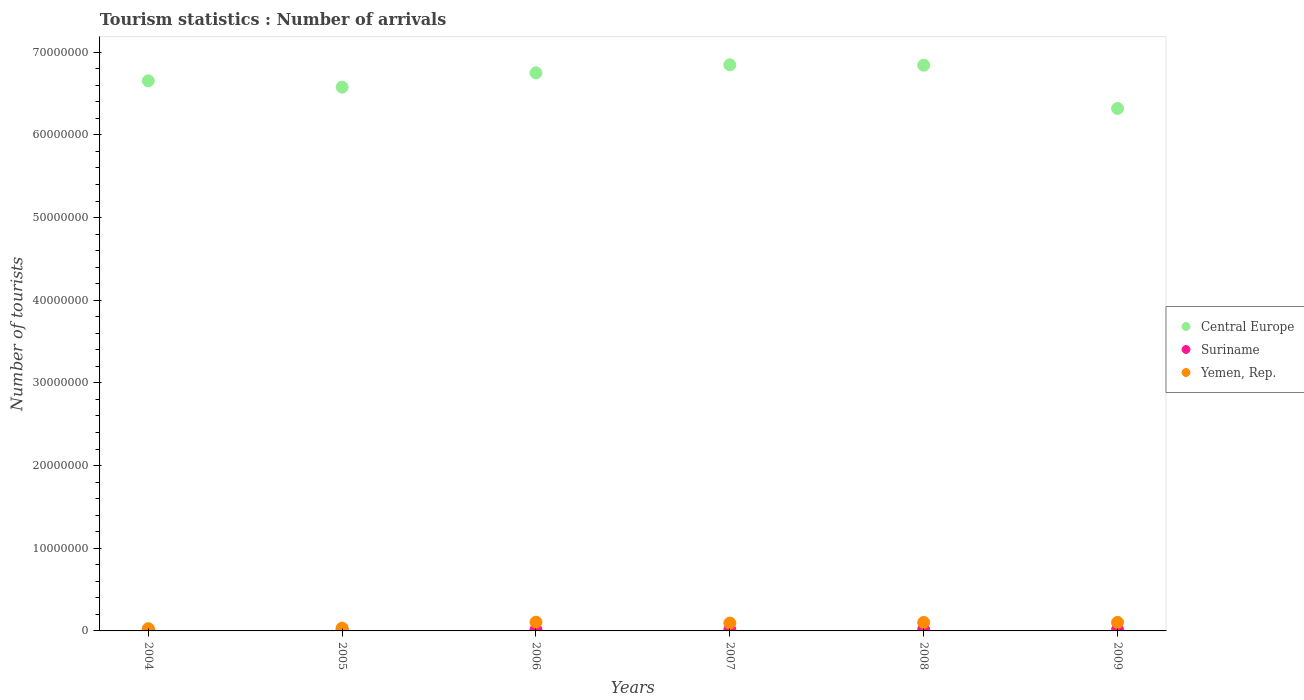Is the number of dotlines equal to the number of legend labels?
Your answer should be very brief. Yes. What is the number of tourist arrivals in Suriname in 2006?
Make the answer very short. 1.54e+05. Across all years, what is the maximum number of tourist arrivals in Suriname?
Offer a very short reply. 1.67e+05. Across all years, what is the minimum number of tourist arrivals in Suriname?
Keep it short and to the point. 1.38e+05. What is the total number of tourist arrivals in Yemen, Rep. in the graph?
Your answer should be compact. 4.67e+06. What is the difference between the number of tourist arrivals in Suriname in 2005 and that in 2006?
Keep it short and to the point. 7000. What is the difference between the number of tourist arrivals in Suriname in 2004 and the number of tourist arrivals in Central Europe in 2008?
Your response must be concise. -6.83e+07. What is the average number of tourist arrivals in Suriname per year?
Ensure brevity in your answer.  1.54e+05. In the year 2008, what is the difference between the number of tourist arrivals in Suriname and number of tourist arrivals in Central Europe?
Keep it short and to the point. -6.83e+07. What is the ratio of the number of tourist arrivals in Suriname in 2004 to that in 2009?
Keep it short and to the point. 0.91. What is the difference between the highest and the second highest number of tourist arrivals in Suriname?
Provide a succinct answer. 6000. What is the difference between the highest and the lowest number of tourist arrivals in Suriname?
Provide a succinct answer. 2.90e+04. Is the sum of the number of tourist arrivals in Yemen, Rep. in 2005 and 2006 greater than the maximum number of tourist arrivals in Central Europe across all years?
Make the answer very short. No. Is it the case that in every year, the sum of the number of tourist arrivals in Yemen, Rep. and number of tourist arrivals in Central Europe  is greater than the number of tourist arrivals in Suriname?
Ensure brevity in your answer.  Yes. Does the number of tourist arrivals in Suriname monotonically increase over the years?
Provide a short and direct response. No. Is the number of tourist arrivals in Yemen, Rep. strictly greater than the number of tourist arrivals in Suriname over the years?
Your answer should be very brief. Yes. Is the number of tourist arrivals in Suriname strictly less than the number of tourist arrivals in Central Europe over the years?
Provide a short and direct response. Yes. How many years are there in the graph?
Provide a short and direct response. 6. What is the difference between two consecutive major ticks on the Y-axis?
Keep it short and to the point. 1.00e+07. Are the values on the major ticks of Y-axis written in scientific E-notation?
Your answer should be very brief. No. Where does the legend appear in the graph?
Offer a terse response. Center right. How many legend labels are there?
Provide a short and direct response. 3. How are the legend labels stacked?
Make the answer very short. Vertical. What is the title of the graph?
Your response must be concise. Tourism statistics : Number of arrivals. What is the label or title of the X-axis?
Offer a terse response. Years. What is the label or title of the Y-axis?
Give a very brief answer. Number of tourists. What is the Number of tourists of Central Europe in 2004?
Provide a short and direct response. 6.65e+07. What is the Number of tourists of Suriname in 2004?
Provide a short and direct response. 1.38e+05. What is the Number of tourists of Yemen, Rep. in 2004?
Your answer should be very brief. 2.74e+05. What is the Number of tourists of Central Europe in 2005?
Your answer should be very brief. 6.58e+07. What is the Number of tourists in Suriname in 2005?
Offer a very short reply. 1.61e+05. What is the Number of tourists of Yemen, Rep. in 2005?
Your answer should be very brief. 3.36e+05. What is the Number of tourists in Central Europe in 2006?
Offer a terse response. 6.75e+07. What is the Number of tourists of Suriname in 2006?
Your response must be concise. 1.54e+05. What is the Number of tourists of Yemen, Rep. in 2006?
Make the answer very short. 1.06e+06. What is the Number of tourists of Central Europe in 2007?
Your response must be concise. 6.85e+07. What is the Number of tourists in Suriname in 2007?
Provide a short and direct response. 1.67e+05. What is the Number of tourists of Yemen, Rep. in 2007?
Ensure brevity in your answer.  9.48e+05. What is the Number of tourists in Central Europe in 2008?
Provide a short and direct response. 6.84e+07. What is the Number of tourists of Suriname in 2008?
Give a very brief answer. 1.51e+05. What is the Number of tourists of Yemen, Rep. in 2008?
Give a very brief answer. 1.02e+06. What is the Number of tourists of Central Europe in 2009?
Your answer should be compact. 6.32e+07. What is the Number of tourists in Suriname in 2009?
Your answer should be compact. 1.51e+05. What is the Number of tourists of Yemen, Rep. in 2009?
Provide a short and direct response. 1.03e+06. Across all years, what is the maximum Number of tourists in Central Europe?
Keep it short and to the point. 6.85e+07. Across all years, what is the maximum Number of tourists in Suriname?
Offer a terse response. 1.67e+05. Across all years, what is the maximum Number of tourists of Yemen, Rep.?
Your response must be concise. 1.06e+06. Across all years, what is the minimum Number of tourists in Central Europe?
Your answer should be compact. 6.32e+07. Across all years, what is the minimum Number of tourists of Suriname?
Your answer should be very brief. 1.38e+05. Across all years, what is the minimum Number of tourists in Yemen, Rep.?
Make the answer very short. 2.74e+05. What is the total Number of tourists in Central Europe in the graph?
Offer a terse response. 4.00e+08. What is the total Number of tourists of Suriname in the graph?
Your response must be concise. 9.22e+05. What is the total Number of tourists of Yemen, Rep. in the graph?
Give a very brief answer. 4.67e+06. What is the difference between the Number of tourists in Central Europe in 2004 and that in 2005?
Provide a short and direct response. 7.64e+05. What is the difference between the Number of tourists of Suriname in 2004 and that in 2005?
Your answer should be very brief. -2.30e+04. What is the difference between the Number of tourists in Yemen, Rep. in 2004 and that in 2005?
Make the answer very short. -6.20e+04. What is the difference between the Number of tourists in Central Europe in 2004 and that in 2006?
Provide a short and direct response. -9.64e+05. What is the difference between the Number of tourists of Suriname in 2004 and that in 2006?
Keep it short and to the point. -1.60e+04. What is the difference between the Number of tourists in Yemen, Rep. in 2004 and that in 2006?
Offer a terse response. -7.87e+05. What is the difference between the Number of tourists of Central Europe in 2004 and that in 2007?
Your response must be concise. -1.94e+06. What is the difference between the Number of tourists of Suriname in 2004 and that in 2007?
Your answer should be very brief. -2.90e+04. What is the difference between the Number of tourists of Yemen, Rep. in 2004 and that in 2007?
Offer a terse response. -6.74e+05. What is the difference between the Number of tourists in Central Europe in 2004 and that in 2008?
Keep it short and to the point. -1.89e+06. What is the difference between the Number of tourists of Suriname in 2004 and that in 2008?
Your response must be concise. -1.30e+04. What is the difference between the Number of tourists in Yemen, Rep. in 2004 and that in 2008?
Your answer should be very brief. -7.49e+05. What is the difference between the Number of tourists of Central Europe in 2004 and that in 2009?
Provide a succinct answer. 3.35e+06. What is the difference between the Number of tourists of Suriname in 2004 and that in 2009?
Keep it short and to the point. -1.30e+04. What is the difference between the Number of tourists in Yemen, Rep. in 2004 and that in 2009?
Give a very brief answer. -7.54e+05. What is the difference between the Number of tourists of Central Europe in 2005 and that in 2006?
Provide a short and direct response. -1.73e+06. What is the difference between the Number of tourists in Suriname in 2005 and that in 2006?
Provide a succinct answer. 7000. What is the difference between the Number of tourists in Yemen, Rep. in 2005 and that in 2006?
Ensure brevity in your answer.  -7.25e+05. What is the difference between the Number of tourists of Central Europe in 2005 and that in 2007?
Keep it short and to the point. -2.70e+06. What is the difference between the Number of tourists of Suriname in 2005 and that in 2007?
Provide a succinct answer. -6000. What is the difference between the Number of tourists of Yemen, Rep. in 2005 and that in 2007?
Provide a short and direct response. -6.12e+05. What is the difference between the Number of tourists in Central Europe in 2005 and that in 2008?
Ensure brevity in your answer.  -2.66e+06. What is the difference between the Number of tourists in Suriname in 2005 and that in 2008?
Make the answer very short. 10000. What is the difference between the Number of tourists of Yemen, Rep. in 2005 and that in 2008?
Provide a succinct answer. -6.87e+05. What is the difference between the Number of tourists in Central Europe in 2005 and that in 2009?
Your answer should be very brief. 2.58e+06. What is the difference between the Number of tourists of Suriname in 2005 and that in 2009?
Provide a short and direct response. 10000. What is the difference between the Number of tourists in Yemen, Rep. in 2005 and that in 2009?
Give a very brief answer. -6.92e+05. What is the difference between the Number of tourists of Central Europe in 2006 and that in 2007?
Provide a short and direct response. -9.72e+05. What is the difference between the Number of tourists of Suriname in 2006 and that in 2007?
Ensure brevity in your answer.  -1.30e+04. What is the difference between the Number of tourists of Yemen, Rep. in 2006 and that in 2007?
Provide a short and direct response. 1.13e+05. What is the difference between the Number of tourists of Central Europe in 2006 and that in 2008?
Give a very brief answer. -9.27e+05. What is the difference between the Number of tourists in Suriname in 2006 and that in 2008?
Provide a short and direct response. 3000. What is the difference between the Number of tourists of Yemen, Rep. in 2006 and that in 2008?
Your response must be concise. 3.80e+04. What is the difference between the Number of tourists of Central Europe in 2006 and that in 2009?
Offer a terse response. 4.31e+06. What is the difference between the Number of tourists in Suriname in 2006 and that in 2009?
Provide a short and direct response. 3000. What is the difference between the Number of tourists in Yemen, Rep. in 2006 and that in 2009?
Your answer should be very brief. 3.30e+04. What is the difference between the Number of tourists of Central Europe in 2007 and that in 2008?
Your answer should be very brief. 4.50e+04. What is the difference between the Number of tourists in Suriname in 2007 and that in 2008?
Your response must be concise. 1.60e+04. What is the difference between the Number of tourists of Yemen, Rep. in 2007 and that in 2008?
Make the answer very short. -7.50e+04. What is the difference between the Number of tourists of Central Europe in 2007 and that in 2009?
Your answer should be very brief. 5.28e+06. What is the difference between the Number of tourists of Suriname in 2007 and that in 2009?
Provide a short and direct response. 1.60e+04. What is the difference between the Number of tourists of Central Europe in 2008 and that in 2009?
Ensure brevity in your answer.  5.24e+06. What is the difference between the Number of tourists in Suriname in 2008 and that in 2009?
Your response must be concise. 0. What is the difference between the Number of tourists in Yemen, Rep. in 2008 and that in 2009?
Ensure brevity in your answer.  -5000. What is the difference between the Number of tourists in Central Europe in 2004 and the Number of tourists in Suriname in 2005?
Ensure brevity in your answer.  6.64e+07. What is the difference between the Number of tourists in Central Europe in 2004 and the Number of tourists in Yemen, Rep. in 2005?
Provide a succinct answer. 6.62e+07. What is the difference between the Number of tourists in Suriname in 2004 and the Number of tourists in Yemen, Rep. in 2005?
Offer a very short reply. -1.98e+05. What is the difference between the Number of tourists in Central Europe in 2004 and the Number of tourists in Suriname in 2006?
Offer a terse response. 6.64e+07. What is the difference between the Number of tourists in Central Europe in 2004 and the Number of tourists in Yemen, Rep. in 2006?
Keep it short and to the point. 6.55e+07. What is the difference between the Number of tourists of Suriname in 2004 and the Number of tourists of Yemen, Rep. in 2006?
Ensure brevity in your answer.  -9.23e+05. What is the difference between the Number of tourists in Central Europe in 2004 and the Number of tourists in Suriname in 2007?
Offer a terse response. 6.64e+07. What is the difference between the Number of tourists in Central Europe in 2004 and the Number of tourists in Yemen, Rep. in 2007?
Keep it short and to the point. 6.56e+07. What is the difference between the Number of tourists of Suriname in 2004 and the Number of tourists of Yemen, Rep. in 2007?
Offer a very short reply. -8.10e+05. What is the difference between the Number of tourists in Central Europe in 2004 and the Number of tourists in Suriname in 2008?
Offer a very short reply. 6.64e+07. What is the difference between the Number of tourists of Central Europe in 2004 and the Number of tourists of Yemen, Rep. in 2008?
Make the answer very short. 6.55e+07. What is the difference between the Number of tourists of Suriname in 2004 and the Number of tourists of Yemen, Rep. in 2008?
Make the answer very short. -8.85e+05. What is the difference between the Number of tourists of Central Europe in 2004 and the Number of tourists of Suriname in 2009?
Provide a succinct answer. 6.64e+07. What is the difference between the Number of tourists of Central Europe in 2004 and the Number of tourists of Yemen, Rep. in 2009?
Your response must be concise. 6.55e+07. What is the difference between the Number of tourists of Suriname in 2004 and the Number of tourists of Yemen, Rep. in 2009?
Keep it short and to the point. -8.90e+05. What is the difference between the Number of tourists in Central Europe in 2005 and the Number of tourists in Suriname in 2006?
Your answer should be compact. 6.56e+07. What is the difference between the Number of tourists of Central Europe in 2005 and the Number of tourists of Yemen, Rep. in 2006?
Offer a terse response. 6.47e+07. What is the difference between the Number of tourists of Suriname in 2005 and the Number of tourists of Yemen, Rep. in 2006?
Your answer should be very brief. -9.00e+05. What is the difference between the Number of tourists in Central Europe in 2005 and the Number of tourists in Suriname in 2007?
Offer a terse response. 6.56e+07. What is the difference between the Number of tourists of Central Europe in 2005 and the Number of tourists of Yemen, Rep. in 2007?
Ensure brevity in your answer.  6.48e+07. What is the difference between the Number of tourists in Suriname in 2005 and the Number of tourists in Yemen, Rep. in 2007?
Give a very brief answer. -7.87e+05. What is the difference between the Number of tourists in Central Europe in 2005 and the Number of tourists in Suriname in 2008?
Ensure brevity in your answer.  6.56e+07. What is the difference between the Number of tourists in Central Europe in 2005 and the Number of tourists in Yemen, Rep. in 2008?
Your answer should be compact. 6.48e+07. What is the difference between the Number of tourists of Suriname in 2005 and the Number of tourists of Yemen, Rep. in 2008?
Offer a terse response. -8.62e+05. What is the difference between the Number of tourists in Central Europe in 2005 and the Number of tourists in Suriname in 2009?
Give a very brief answer. 6.56e+07. What is the difference between the Number of tourists in Central Europe in 2005 and the Number of tourists in Yemen, Rep. in 2009?
Make the answer very short. 6.47e+07. What is the difference between the Number of tourists of Suriname in 2005 and the Number of tourists of Yemen, Rep. in 2009?
Give a very brief answer. -8.67e+05. What is the difference between the Number of tourists in Central Europe in 2006 and the Number of tourists in Suriname in 2007?
Ensure brevity in your answer.  6.73e+07. What is the difference between the Number of tourists in Central Europe in 2006 and the Number of tourists in Yemen, Rep. in 2007?
Your response must be concise. 6.66e+07. What is the difference between the Number of tourists in Suriname in 2006 and the Number of tourists in Yemen, Rep. in 2007?
Make the answer very short. -7.94e+05. What is the difference between the Number of tourists of Central Europe in 2006 and the Number of tourists of Suriname in 2008?
Keep it short and to the point. 6.74e+07. What is the difference between the Number of tourists in Central Europe in 2006 and the Number of tourists in Yemen, Rep. in 2008?
Ensure brevity in your answer.  6.65e+07. What is the difference between the Number of tourists in Suriname in 2006 and the Number of tourists in Yemen, Rep. in 2008?
Your answer should be compact. -8.69e+05. What is the difference between the Number of tourists in Central Europe in 2006 and the Number of tourists in Suriname in 2009?
Offer a very short reply. 6.74e+07. What is the difference between the Number of tourists of Central Europe in 2006 and the Number of tourists of Yemen, Rep. in 2009?
Your answer should be very brief. 6.65e+07. What is the difference between the Number of tourists of Suriname in 2006 and the Number of tourists of Yemen, Rep. in 2009?
Keep it short and to the point. -8.74e+05. What is the difference between the Number of tourists of Central Europe in 2007 and the Number of tourists of Suriname in 2008?
Give a very brief answer. 6.83e+07. What is the difference between the Number of tourists of Central Europe in 2007 and the Number of tourists of Yemen, Rep. in 2008?
Your answer should be very brief. 6.75e+07. What is the difference between the Number of tourists in Suriname in 2007 and the Number of tourists in Yemen, Rep. in 2008?
Offer a very short reply. -8.56e+05. What is the difference between the Number of tourists in Central Europe in 2007 and the Number of tourists in Suriname in 2009?
Your answer should be very brief. 6.83e+07. What is the difference between the Number of tourists of Central Europe in 2007 and the Number of tourists of Yemen, Rep. in 2009?
Make the answer very short. 6.74e+07. What is the difference between the Number of tourists in Suriname in 2007 and the Number of tourists in Yemen, Rep. in 2009?
Offer a terse response. -8.61e+05. What is the difference between the Number of tourists in Central Europe in 2008 and the Number of tourists in Suriname in 2009?
Provide a succinct answer. 6.83e+07. What is the difference between the Number of tourists of Central Europe in 2008 and the Number of tourists of Yemen, Rep. in 2009?
Your response must be concise. 6.74e+07. What is the difference between the Number of tourists of Suriname in 2008 and the Number of tourists of Yemen, Rep. in 2009?
Your answer should be compact. -8.77e+05. What is the average Number of tourists of Central Europe per year?
Make the answer very short. 6.67e+07. What is the average Number of tourists in Suriname per year?
Your answer should be very brief. 1.54e+05. What is the average Number of tourists of Yemen, Rep. per year?
Offer a terse response. 7.78e+05. In the year 2004, what is the difference between the Number of tourists in Central Europe and Number of tourists in Suriname?
Your answer should be compact. 6.64e+07. In the year 2004, what is the difference between the Number of tourists in Central Europe and Number of tourists in Yemen, Rep.?
Make the answer very short. 6.63e+07. In the year 2004, what is the difference between the Number of tourists in Suriname and Number of tourists in Yemen, Rep.?
Your answer should be very brief. -1.36e+05. In the year 2005, what is the difference between the Number of tourists in Central Europe and Number of tourists in Suriname?
Keep it short and to the point. 6.56e+07. In the year 2005, what is the difference between the Number of tourists of Central Europe and Number of tourists of Yemen, Rep.?
Provide a succinct answer. 6.54e+07. In the year 2005, what is the difference between the Number of tourists of Suriname and Number of tourists of Yemen, Rep.?
Make the answer very short. -1.75e+05. In the year 2006, what is the difference between the Number of tourists in Central Europe and Number of tourists in Suriname?
Give a very brief answer. 6.73e+07. In the year 2006, what is the difference between the Number of tourists in Central Europe and Number of tourists in Yemen, Rep.?
Offer a very short reply. 6.64e+07. In the year 2006, what is the difference between the Number of tourists in Suriname and Number of tourists in Yemen, Rep.?
Make the answer very short. -9.07e+05. In the year 2007, what is the difference between the Number of tourists in Central Europe and Number of tourists in Suriname?
Give a very brief answer. 6.83e+07. In the year 2007, what is the difference between the Number of tourists of Central Europe and Number of tourists of Yemen, Rep.?
Keep it short and to the point. 6.75e+07. In the year 2007, what is the difference between the Number of tourists in Suriname and Number of tourists in Yemen, Rep.?
Give a very brief answer. -7.81e+05. In the year 2008, what is the difference between the Number of tourists in Central Europe and Number of tourists in Suriname?
Your response must be concise. 6.83e+07. In the year 2008, what is the difference between the Number of tourists in Central Europe and Number of tourists in Yemen, Rep.?
Your response must be concise. 6.74e+07. In the year 2008, what is the difference between the Number of tourists of Suriname and Number of tourists of Yemen, Rep.?
Your answer should be compact. -8.72e+05. In the year 2009, what is the difference between the Number of tourists of Central Europe and Number of tourists of Suriname?
Make the answer very short. 6.30e+07. In the year 2009, what is the difference between the Number of tourists of Central Europe and Number of tourists of Yemen, Rep.?
Give a very brief answer. 6.22e+07. In the year 2009, what is the difference between the Number of tourists in Suriname and Number of tourists in Yemen, Rep.?
Give a very brief answer. -8.77e+05. What is the ratio of the Number of tourists of Central Europe in 2004 to that in 2005?
Offer a terse response. 1.01. What is the ratio of the Number of tourists in Yemen, Rep. in 2004 to that in 2005?
Provide a short and direct response. 0.82. What is the ratio of the Number of tourists of Central Europe in 2004 to that in 2006?
Offer a very short reply. 0.99. What is the ratio of the Number of tourists in Suriname in 2004 to that in 2006?
Offer a very short reply. 0.9. What is the ratio of the Number of tourists in Yemen, Rep. in 2004 to that in 2006?
Provide a short and direct response. 0.26. What is the ratio of the Number of tourists of Central Europe in 2004 to that in 2007?
Your response must be concise. 0.97. What is the ratio of the Number of tourists in Suriname in 2004 to that in 2007?
Offer a very short reply. 0.83. What is the ratio of the Number of tourists of Yemen, Rep. in 2004 to that in 2007?
Your answer should be compact. 0.29. What is the ratio of the Number of tourists in Central Europe in 2004 to that in 2008?
Ensure brevity in your answer.  0.97. What is the ratio of the Number of tourists of Suriname in 2004 to that in 2008?
Your answer should be compact. 0.91. What is the ratio of the Number of tourists of Yemen, Rep. in 2004 to that in 2008?
Give a very brief answer. 0.27. What is the ratio of the Number of tourists of Central Europe in 2004 to that in 2009?
Offer a terse response. 1.05. What is the ratio of the Number of tourists in Suriname in 2004 to that in 2009?
Offer a terse response. 0.91. What is the ratio of the Number of tourists of Yemen, Rep. in 2004 to that in 2009?
Offer a terse response. 0.27. What is the ratio of the Number of tourists of Central Europe in 2005 to that in 2006?
Keep it short and to the point. 0.97. What is the ratio of the Number of tourists of Suriname in 2005 to that in 2006?
Your answer should be compact. 1.05. What is the ratio of the Number of tourists of Yemen, Rep. in 2005 to that in 2006?
Provide a succinct answer. 0.32. What is the ratio of the Number of tourists in Central Europe in 2005 to that in 2007?
Offer a terse response. 0.96. What is the ratio of the Number of tourists in Suriname in 2005 to that in 2007?
Your answer should be very brief. 0.96. What is the ratio of the Number of tourists of Yemen, Rep. in 2005 to that in 2007?
Offer a terse response. 0.35. What is the ratio of the Number of tourists of Central Europe in 2005 to that in 2008?
Your answer should be compact. 0.96. What is the ratio of the Number of tourists in Suriname in 2005 to that in 2008?
Give a very brief answer. 1.07. What is the ratio of the Number of tourists in Yemen, Rep. in 2005 to that in 2008?
Offer a terse response. 0.33. What is the ratio of the Number of tourists of Central Europe in 2005 to that in 2009?
Your response must be concise. 1.04. What is the ratio of the Number of tourists of Suriname in 2005 to that in 2009?
Your response must be concise. 1.07. What is the ratio of the Number of tourists of Yemen, Rep. in 2005 to that in 2009?
Provide a succinct answer. 0.33. What is the ratio of the Number of tourists of Central Europe in 2006 to that in 2007?
Offer a very short reply. 0.99. What is the ratio of the Number of tourists of Suriname in 2006 to that in 2007?
Offer a very short reply. 0.92. What is the ratio of the Number of tourists in Yemen, Rep. in 2006 to that in 2007?
Your answer should be very brief. 1.12. What is the ratio of the Number of tourists of Central Europe in 2006 to that in 2008?
Provide a succinct answer. 0.99. What is the ratio of the Number of tourists in Suriname in 2006 to that in 2008?
Your answer should be very brief. 1.02. What is the ratio of the Number of tourists in Yemen, Rep. in 2006 to that in 2008?
Your answer should be compact. 1.04. What is the ratio of the Number of tourists in Central Europe in 2006 to that in 2009?
Offer a very short reply. 1.07. What is the ratio of the Number of tourists of Suriname in 2006 to that in 2009?
Make the answer very short. 1.02. What is the ratio of the Number of tourists in Yemen, Rep. in 2006 to that in 2009?
Provide a short and direct response. 1.03. What is the ratio of the Number of tourists of Central Europe in 2007 to that in 2008?
Your answer should be compact. 1. What is the ratio of the Number of tourists of Suriname in 2007 to that in 2008?
Offer a terse response. 1.11. What is the ratio of the Number of tourists of Yemen, Rep. in 2007 to that in 2008?
Give a very brief answer. 0.93. What is the ratio of the Number of tourists of Central Europe in 2007 to that in 2009?
Offer a terse response. 1.08. What is the ratio of the Number of tourists of Suriname in 2007 to that in 2009?
Provide a succinct answer. 1.11. What is the ratio of the Number of tourists of Yemen, Rep. in 2007 to that in 2009?
Make the answer very short. 0.92. What is the ratio of the Number of tourists in Central Europe in 2008 to that in 2009?
Make the answer very short. 1.08. What is the ratio of the Number of tourists in Yemen, Rep. in 2008 to that in 2009?
Provide a short and direct response. 1. What is the difference between the highest and the second highest Number of tourists in Central Europe?
Your response must be concise. 4.50e+04. What is the difference between the highest and the second highest Number of tourists in Suriname?
Offer a terse response. 6000. What is the difference between the highest and the second highest Number of tourists in Yemen, Rep.?
Keep it short and to the point. 3.30e+04. What is the difference between the highest and the lowest Number of tourists of Central Europe?
Provide a short and direct response. 5.28e+06. What is the difference between the highest and the lowest Number of tourists of Suriname?
Offer a very short reply. 2.90e+04. What is the difference between the highest and the lowest Number of tourists in Yemen, Rep.?
Your answer should be compact. 7.87e+05. 